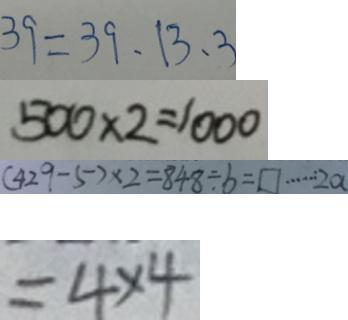<formula> <loc_0><loc_0><loc_500><loc_500>3 9 = 3 9 , 1 3 , 3 
 5 0 0 \times 2 = 1 0 0 0 
 ( 4 2 9 - 5 ) \times 2 = 8 4 8 \div b = \square \cdots 2 a 
 = 4 \times 4</formula> 